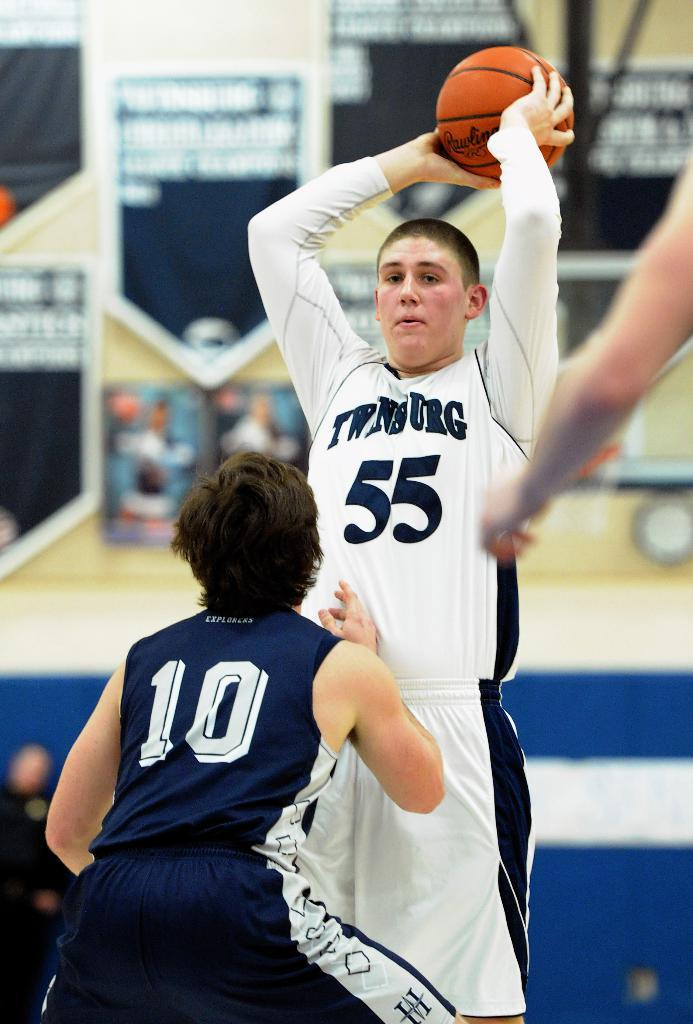<image>
Summarize the visual content of the image. A boy wearing a number 55 jersey holds a basketball and stands above a person wearing a jersey with the number 10. 